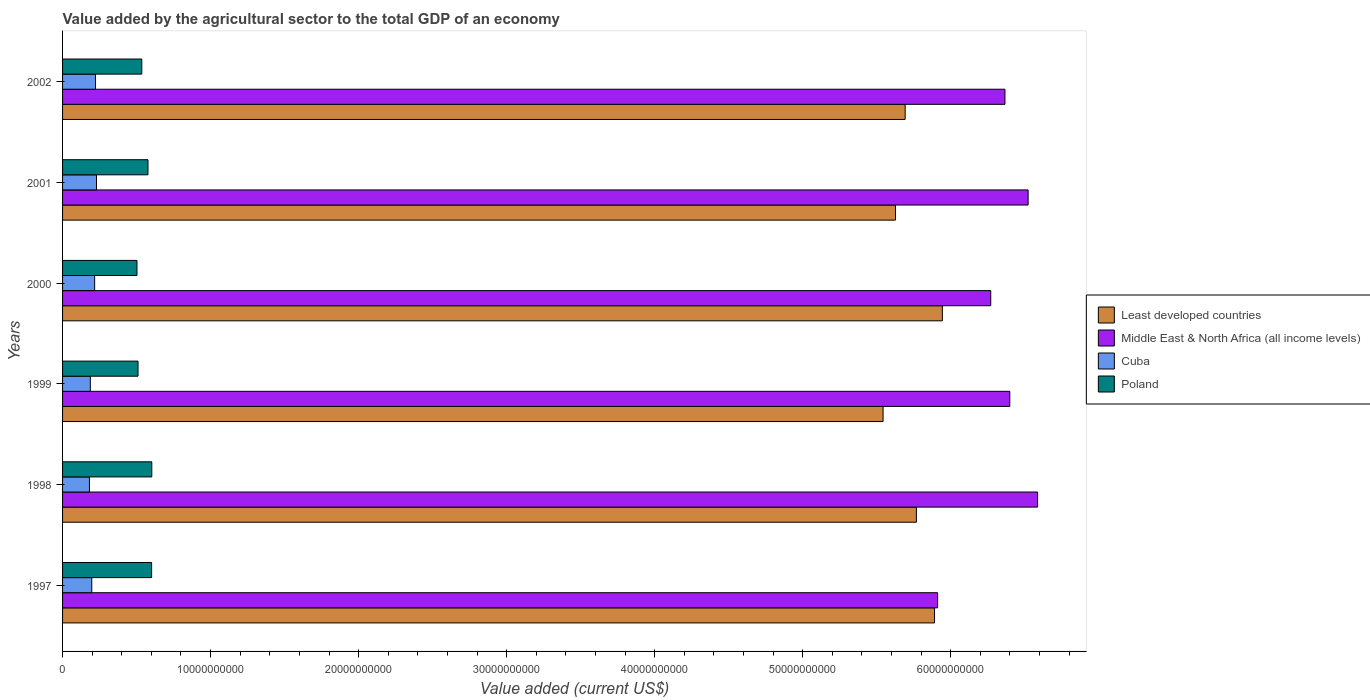How many different coloured bars are there?
Your response must be concise. 4. How many groups of bars are there?
Keep it short and to the point. 6. Are the number of bars per tick equal to the number of legend labels?
Offer a terse response. Yes. Are the number of bars on each tick of the Y-axis equal?
Offer a very short reply. Yes. How many bars are there on the 6th tick from the bottom?
Provide a short and direct response. 4. In how many cases, is the number of bars for a given year not equal to the number of legend labels?
Ensure brevity in your answer.  0. What is the value added by the agricultural sector to the total GDP in Poland in 1997?
Your response must be concise. 6.02e+09. Across all years, what is the maximum value added by the agricultural sector to the total GDP in Least developed countries?
Your answer should be very brief. 5.94e+1. Across all years, what is the minimum value added by the agricultural sector to the total GDP in Middle East & North Africa (all income levels)?
Ensure brevity in your answer.  5.91e+1. What is the total value added by the agricultural sector to the total GDP in Least developed countries in the graph?
Ensure brevity in your answer.  3.45e+11. What is the difference between the value added by the agricultural sector to the total GDP in Least developed countries in 1999 and that in 2000?
Offer a terse response. -4.00e+09. What is the difference between the value added by the agricultural sector to the total GDP in Poland in 1997 and the value added by the agricultural sector to the total GDP in Least developed countries in 1998?
Give a very brief answer. -5.17e+1. What is the average value added by the agricultural sector to the total GDP in Cuba per year?
Your answer should be compact. 2.06e+09. In the year 2001, what is the difference between the value added by the agricultural sector to the total GDP in Middle East & North Africa (all income levels) and value added by the agricultural sector to the total GDP in Least developed countries?
Give a very brief answer. 8.96e+09. In how many years, is the value added by the agricultural sector to the total GDP in Cuba greater than 10000000000 US$?
Offer a very short reply. 0. What is the ratio of the value added by the agricultural sector to the total GDP in Least developed countries in 2001 to that in 2002?
Keep it short and to the point. 0.99. Is the value added by the agricultural sector to the total GDP in Middle East & North Africa (all income levels) in 2001 less than that in 2002?
Provide a short and direct response. No. Is the difference between the value added by the agricultural sector to the total GDP in Middle East & North Africa (all income levels) in 1999 and 2002 greater than the difference between the value added by the agricultural sector to the total GDP in Least developed countries in 1999 and 2002?
Your response must be concise. Yes. What is the difference between the highest and the second highest value added by the agricultural sector to the total GDP in Middle East & North Africa (all income levels)?
Provide a succinct answer. 6.39e+08. What is the difference between the highest and the lowest value added by the agricultural sector to the total GDP in Middle East & North Africa (all income levels)?
Provide a short and direct response. 6.75e+09. Is the sum of the value added by the agricultural sector to the total GDP in Cuba in 2000 and 2002 greater than the maximum value added by the agricultural sector to the total GDP in Poland across all years?
Give a very brief answer. No. Is it the case that in every year, the sum of the value added by the agricultural sector to the total GDP in Least developed countries and value added by the agricultural sector to the total GDP in Middle East & North Africa (all income levels) is greater than the sum of value added by the agricultural sector to the total GDP in Poland and value added by the agricultural sector to the total GDP in Cuba?
Keep it short and to the point. Yes. What does the 3rd bar from the top in 1997 represents?
Your answer should be compact. Middle East & North Africa (all income levels). What does the 2nd bar from the bottom in 2000 represents?
Give a very brief answer. Middle East & North Africa (all income levels). Are all the bars in the graph horizontal?
Your answer should be compact. Yes. What is the difference between two consecutive major ticks on the X-axis?
Keep it short and to the point. 1.00e+1. Are the values on the major ticks of X-axis written in scientific E-notation?
Give a very brief answer. No. Does the graph contain any zero values?
Provide a succinct answer. No. Does the graph contain grids?
Give a very brief answer. No. Where does the legend appear in the graph?
Your answer should be compact. Center right. How are the legend labels stacked?
Your response must be concise. Vertical. What is the title of the graph?
Offer a very short reply. Value added by the agricultural sector to the total GDP of an economy. Does "Least developed countries" appear as one of the legend labels in the graph?
Keep it short and to the point. Yes. What is the label or title of the X-axis?
Your answer should be compact. Value added (current US$). What is the label or title of the Y-axis?
Provide a short and direct response. Years. What is the Value added (current US$) of Least developed countries in 1997?
Your answer should be compact. 5.89e+1. What is the Value added (current US$) of Middle East & North Africa (all income levels) in 1997?
Offer a very short reply. 5.91e+1. What is the Value added (current US$) of Cuba in 1997?
Offer a terse response. 1.97e+09. What is the Value added (current US$) of Poland in 1997?
Ensure brevity in your answer.  6.02e+09. What is the Value added (current US$) of Least developed countries in 1998?
Provide a succinct answer. 5.77e+1. What is the Value added (current US$) of Middle East & North Africa (all income levels) in 1998?
Provide a succinct answer. 6.59e+1. What is the Value added (current US$) of Cuba in 1998?
Offer a terse response. 1.82e+09. What is the Value added (current US$) of Poland in 1998?
Make the answer very short. 6.03e+09. What is the Value added (current US$) in Least developed countries in 1999?
Keep it short and to the point. 5.54e+1. What is the Value added (current US$) of Middle East & North Africa (all income levels) in 1999?
Offer a very short reply. 6.40e+1. What is the Value added (current US$) in Cuba in 1999?
Your answer should be compact. 1.87e+09. What is the Value added (current US$) in Poland in 1999?
Make the answer very short. 5.10e+09. What is the Value added (current US$) of Least developed countries in 2000?
Ensure brevity in your answer.  5.94e+1. What is the Value added (current US$) in Middle East & North Africa (all income levels) in 2000?
Provide a succinct answer. 6.27e+1. What is the Value added (current US$) in Cuba in 2000?
Provide a short and direct response. 2.17e+09. What is the Value added (current US$) of Poland in 2000?
Your answer should be compact. 5.03e+09. What is the Value added (current US$) of Least developed countries in 2001?
Ensure brevity in your answer.  5.63e+1. What is the Value added (current US$) of Middle East & North Africa (all income levels) in 2001?
Provide a short and direct response. 6.52e+1. What is the Value added (current US$) of Cuba in 2001?
Give a very brief answer. 2.29e+09. What is the Value added (current US$) of Poland in 2001?
Your answer should be very brief. 5.77e+09. What is the Value added (current US$) in Least developed countries in 2002?
Give a very brief answer. 5.69e+1. What is the Value added (current US$) of Middle East & North Africa (all income levels) in 2002?
Ensure brevity in your answer.  6.37e+1. What is the Value added (current US$) of Cuba in 2002?
Your answer should be compact. 2.23e+09. What is the Value added (current US$) of Poland in 2002?
Offer a very short reply. 5.35e+09. Across all years, what is the maximum Value added (current US$) of Least developed countries?
Keep it short and to the point. 5.94e+1. Across all years, what is the maximum Value added (current US$) of Middle East & North Africa (all income levels)?
Provide a short and direct response. 6.59e+1. Across all years, what is the maximum Value added (current US$) in Cuba?
Your response must be concise. 2.29e+09. Across all years, what is the maximum Value added (current US$) in Poland?
Provide a short and direct response. 6.03e+09. Across all years, what is the minimum Value added (current US$) in Least developed countries?
Provide a short and direct response. 5.54e+1. Across all years, what is the minimum Value added (current US$) of Middle East & North Africa (all income levels)?
Offer a terse response. 5.91e+1. Across all years, what is the minimum Value added (current US$) of Cuba?
Provide a succinct answer. 1.82e+09. Across all years, what is the minimum Value added (current US$) in Poland?
Offer a very short reply. 5.03e+09. What is the total Value added (current US$) in Least developed countries in the graph?
Make the answer very short. 3.45e+11. What is the total Value added (current US$) of Middle East & North Africa (all income levels) in the graph?
Your response must be concise. 3.81e+11. What is the total Value added (current US$) in Cuba in the graph?
Make the answer very short. 1.23e+1. What is the total Value added (current US$) of Poland in the graph?
Make the answer very short. 3.33e+1. What is the difference between the Value added (current US$) in Least developed countries in 1997 and that in 1998?
Your answer should be very brief. 1.23e+09. What is the difference between the Value added (current US$) of Middle East & North Africa (all income levels) in 1997 and that in 1998?
Your response must be concise. -6.75e+09. What is the difference between the Value added (current US$) of Cuba in 1997 and that in 1998?
Provide a short and direct response. 1.57e+08. What is the difference between the Value added (current US$) in Poland in 1997 and that in 1998?
Provide a succinct answer. -1.11e+07. What is the difference between the Value added (current US$) of Least developed countries in 1997 and that in 1999?
Make the answer very short. 3.48e+09. What is the difference between the Value added (current US$) in Middle East & North Africa (all income levels) in 1997 and that in 1999?
Ensure brevity in your answer.  -4.88e+09. What is the difference between the Value added (current US$) in Cuba in 1997 and that in 1999?
Offer a very short reply. 9.82e+07. What is the difference between the Value added (current US$) in Poland in 1997 and that in 1999?
Offer a terse response. 9.19e+08. What is the difference between the Value added (current US$) of Least developed countries in 1997 and that in 2000?
Keep it short and to the point. -5.29e+08. What is the difference between the Value added (current US$) in Middle East & North Africa (all income levels) in 1997 and that in 2000?
Ensure brevity in your answer.  -3.59e+09. What is the difference between the Value added (current US$) of Cuba in 1997 and that in 2000?
Keep it short and to the point. -1.94e+08. What is the difference between the Value added (current US$) in Poland in 1997 and that in 2000?
Provide a succinct answer. 9.90e+08. What is the difference between the Value added (current US$) in Least developed countries in 1997 and that in 2001?
Keep it short and to the point. 2.64e+09. What is the difference between the Value added (current US$) in Middle East & North Africa (all income levels) in 1997 and that in 2001?
Offer a terse response. -6.11e+09. What is the difference between the Value added (current US$) in Cuba in 1997 and that in 2001?
Offer a terse response. -3.20e+08. What is the difference between the Value added (current US$) in Poland in 1997 and that in 2001?
Provide a short and direct response. 2.46e+08. What is the difference between the Value added (current US$) in Least developed countries in 1997 and that in 2002?
Offer a terse response. 1.98e+09. What is the difference between the Value added (current US$) in Middle East & North Africa (all income levels) in 1997 and that in 2002?
Offer a terse response. -4.55e+09. What is the difference between the Value added (current US$) of Cuba in 1997 and that in 2002?
Make the answer very short. -2.53e+08. What is the difference between the Value added (current US$) of Poland in 1997 and that in 2002?
Give a very brief answer. 6.64e+08. What is the difference between the Value added (current US$) of Least developed countries in 1998 and that in 1999?
Offer a very short reply. 2.25e+09. What is the difference between the Value added (current US$) in Middle East & North Africa (all income levels) in 1998 and that in 1999?
Provide a short and direct response. 1.88e+09. What is the difference between the Value added (current US$) of Cuba in 1998 and that in 1999?
Offer a very short reply. -5.87e+07. What is the difference between the Value added (current US$) in Poland in 1998 and that in 1999?
Provide a succinct answer. 9.30e+08. What is the difference between the Value added (current US$) in Least developed countries in 1998 and that in 2000?
Your answer should be compact. -1.75e+09. What is the difference between the Value added (current US$) of Middle East & North Africa (all income levels) in 1998 and that in 2000?
Your answer should be very brief. 3.16e+09. What is the difference between the Value added (current US$) of Cuba in 1998 and that in 2000?
Your answer should be compact. -3.51e+08. What is the difference between the Value added (current US$) in Poland in 1998 and that in 2000?
Ensure brevity in your answer.  1.00e+09. What is the difference between the Value added (current US$) of Least developed countries in 1998 and that in 2001?
Give a very brief answer. 1.41e+09. What is the difference between the Value added (current US$) of Middle East & North Africa (all income levels) in 1998 and that in 2001?
Offer a very short reply. 6.39e+08. What is the difference between the Value added (current US$) in Cuba in 1998 and that in 2001?
Keep it short and to the point. -4.77e+08. What is the difference between the Value added (current US$) in Poland in 1998 and that in 2001?
Your answer should be very brief. 2.57e+08. What is the difference between the Value added (current US$) of Least developed countries in 1998 and that in 2002?
Offer a very short reply. 7.59e+08. What is the difference between the Value added (current US$) of Middle East & North Africa (all income levels) in 1998 and that in 2002?
Make the answer very short. 2.20e+09. What is the difference between the Value added (current US$) in Cuba in 1998 and that in 2002?
Your answer should be compact. -4.10e+08. What is the difference between the Value added (current US$) in Poland in 1998 and that in 2002?
Your answer should be very brief. 6.75e+08. What is the difference between the Value added (current US$) of Least developed countries in 1999 and that in 2000?
Provide a succinct answer. -4.00e+09. What is the difference between the Value added (current US$) of Middle East & North Africa (all income levels) in 1999 and that in 2000?
Offer a very short reply. 1.29e+09. What is the difference between the Value added (current US$) of Cuba in 1999 and that in 2000?
Keep it short and to the point. -2.92e+08. What is the difference between the Value added (current US$) of Poland in 1999 and that in 2000?
Offer a terse response. 7.14e+07. What is the difference between the Value added (current US$) of Least developed countries in 1999 and that in 2001?
Ensure brevity in your answer.  -8.40e+08. What is the difference between the Value added (current US$) of Middle East & North Africa (all income levels) in 1999 and that in 2001?
Give a very brief answer. -1.24e+09. What is the difference between the Value added (current US$) of Cuba in 1999 and that in 2001?
Offer a very short reply. -4.18e+08. What is the difference between the Value added (current US$) in Poland in 1999 and that in 2001?
Offer a terse response. -6.73e+08. What is the difference between the Value added (current US$) in Least developed countries in 1999 and that in 2002?
Your response must be concise. -1.49e+09. What is the difference between the Value added (current US$) of Middle East & North Africa (all income levels) in 1999 and that in 2002?
Keep it short and to the point. 3.27e+08. What is the difference between the Value added (current US$) of Cuba in 1999 and that in 2002?
Keep it short and to the point. -3.51e+08. What is the difference between the Value added (current US$) in Poland in 1999 and that in 2002?
Provide a short and direct response. -2.55e+08. What is the difference between the Value added (current US$) in Least developed countries in 2000 and that in 2001?
Keep it short and to the point. 3.16e+09. What is the difference between the Value added (current US$) of Middle East & North Africa (all income levels) in 2000 and that in 2001?
Your response must be concise. -2.53e+09. What is the difference between the Value added (current US$) of Cuba in 2000 and that in 2001?
Offer a very short reply. -1.26e+08. What is the difference between the Value added (current US$) in Poland in 2000 and that in 2001?
Offer a terse response. -7.45e+08. What is the difference between the Value added (current US$) in Least developed countries in 2000 and that in 2002?
Your answer should be very brief. 2.51e+09. What is the difference between the Value added (current US$) in Middle East & North Africa (all income levels) in 2000 and that in 2002?
Offer a very short reply. -9.59e+08. What is the difference between the Value added (current US$) in Cuba in 2000 and that in 2002?
Provide a succinct answer. -5.92e+07. What is the difference between the Value added (current US$) of Poland in 2000 and that in 2002?
Keep it short and to the point. -3.26e+08. What is the difference between the Value added (current US$) in Least developed countries in 2001 and that in 2002?
Offer a terse response. -6.51e+08. What is the difference between the Value added (current US$) in Middle East & North Africa (all income levels) in 2001 and that in 2002?
Your response must be concise. 1.57e+09. What is the difference between the Value added (current US$) of Cuba in 2001 and that in 2002?
Your answer should be compact. 6.67e+07. What is the difference between the Value added (current US$) in Poland in 2001 and that in 2002?
Provide a short and direct response. 4.18e+08. What is the difference between the Value added (current US$) of Least developed countries in 1997 and the Value added (current US$) of Middle East & North Africa (all income levels) in 1998?
Your answer should be compact. -6.96e+09. What is the difference between the Value added (current US$) of Least developed countries in 1997 and the Value added (current US$) of Cuba in 1998?
Your answer should be compact. 5.71e+1. What is the difference between the Value added (current US$) of Least developed countries in 1997 and the Value added (current US$) of Poland in 1998?
Your response must be concise. 5.29e+1. What is the difference between the Value added (current US$) of Middle East & North Africa (all income levels) in 1997 and the Value added (current US$) of Cuba in 1998?
Provide a succinct answer. 5.73e+1. What is the difference between the Value added (current US$) of Middle East & North Africa (all income levels) in 1997 and the Value added (current US$) of Poland in 1998?
Offer a terse response. 5.31e+1. What is the difference between the Value added (current US$) of Cuba in 1997 and the Value added (current US$) of Poland in 1998?
Give a very brief answer. -4.06e+09. What is the difference between the Value added (current US$) of Least developed countries in 1997 and the Value added (current US$) of Middle East & North Africa (all income levels) in 1999?
Provide a succinct answer. -5.08e+09. What is the difference between the Value added (current US$) of Least developed countries in 1997 and the Value added (current US$) of Cuba in 1999?
Offer a terse response. 5.70e+1. What is the difference between the Value added (current US$) in Least developed countries in 1997 and the Value added (current US$) in Poland in 1999?
Ensure brevity in your answer.  5.38e+1. What is the difference between the Value added (current US$) of Middle East & North Africa (all income levels) in 1997 and the Value added (current US$) of Cuba in 1999?
Make the answer very short. 5.72e+1. What is the difference between the Value added (current US$) of Middle East & North Africa (all income levels) in 1997 and the Value added (current US$) of Poland in 1999?
Give a very brief answer. 5.40e+1. What is the difference between the Value added (current US$) in Cuba in 1997 and the Value added (current US$) in Poland in 1999?
Your answer should be compact. -3.13e+09. What is the difference between the Value added (current US$) in Least developed countries in 1997 and the Value added (current US$) in Middle East & North Africa (all income levels) in 2000?
Your response must be concise. -3.80e+09. What is the difference between the Value added (current US$) of Least developed countries in 1997 and the Value added (current US$) of Cuba in 2000?
Your answer should be very brief. 5.67e+1. What is the difference between the Value added (current US$) in Least developed countries in 1997 and the Value added (current US$) in Poland in 2000?
Offer a terse response. 5.39e+1. What is the difference between the Value added (current US$) in Middle East & North Africa (all income levels) in 1997 and the Value added (current US$) in Cuba in 2000?
Offer a very short reply. 5.69e+1. What is the difference between the Value added (current US$) in Middle East & North Africa (all income levels) in 1997 and the Value added (current US$) in Poland in 2000?
Your response must be concise. 5.41e+1. What is the difference between the Value added (current US$) in Cuba in 1997 and the Value added (current US$) in Poland in 2000?
Ensure brevity in your answer.  -3.05e+09. What is the difference between the Value added (current US$) in Least developed countries in 1997 and the Value added (current US$) in Middle East & North Africa (all income levels) in 2001?
Your response must be concise. -6.32e+09. What is the difference between the Value added (current US$) of Least developed countries in 1997 and the Value added (current US$) of Cuba in 2001?
Offer a terse response. 5.66e+1. What is the difference between the Value added (current US$) in Least developed countries in 1997 and the Value added (current US$) in Poland in 2001?
Provide a succinct answer. 5.31e+1. What is the difference between the Value added (current US$) of Middle East & North Africa (all income levels) in 1997 and the Value added (current US$) of Cuba in 2001?
Make the answer very short. 5.68e+1. What is the difference between the Value added (current US$) in Middle East & North Africa (all income levels) in 1997 and the Value added (current US$) in Poland in 2001?
Provide a short and direct response. 5.33e+1. What is the difference between the Value added (current US$) of Cuba in 1997 and the Value added (current US$) of Poland in 2001?
Offer a terse response. -3.80e+09. What is the difference between the Value added (current US$) in Least developed countries in 1997 and the Value added (current US$) in Middle East & North Africa (all income levels) in 2002?
Provide a succinct answer. -4.76e+09. What is the difference between the Value added (current US$) in Least developed countries in 1997 and the Value added (current US$) in Cuba in 2002?
Your answer should be very brief. 5.67e+1. What is the difference between the Value added (current US$) in Least developed countries in 1997 and the Value added (current US$) in Poland in 2002?
Keep it short and to the point. 5.36e+1. What is the difference between the Value added (current US$) of Middle East & North Africa (all income levels) in 1997 and the Value added (current US$) of Cuba in 2002?
Provide a short and direct response. 5.69e+1. What is the difference between the Value added (current US$) in Middle East & North Africa (all income levels) in 1997 and the Value added (current US$) in Poland in 2002?
Offer a very short reply. 5.38e+1. What is the difference between the Value added (current US$) in Cuba in 1997 and the Value added (current US$) in Poland in 2002?
Your response must be concise. -3.38e+09. What is the difference between the Value added (current US$) of Least developed countries in 1998 and the Value added (current US$) of Middle East & North Africa (all income levels) in 1999?
Give a very brief answer. -6.31e+09. What is the difference between the Value added (current US$) in Least developed countries in 1998 and the Value added (current US$) in Cuba in 1999?
Your answer should be compact. 5.58e+1. What is the difference between the Value added (current US$) in Least developed countries in 1998 and the Value added (current US$) in Poland in 1999?
Provide a succinct answer. 5.26e+1. What is the difference between the Value added (current US$) in Middle East & North Africa (all income levels) in 1998 and the Value added (current US$) in Cuba in 1999?
Give a very brief answer. 6.40e+1. What is the difference between the Value added (current US$) of Middle East & North Africa (all income levels) in 1998 and the Value added (current US$) of Poland in 1999?
Provide a succinct answer. 6.08e+1. What is the difference between the Value added (current US$) of Cuba in 1998 and the Value added (current US$) of Poland in 1999?
Your answer should be very brief. -3.28e+09. What is the difference between the Value added (current US$) of Least developed countries in 1998 and the Value added (current US$) of Middle East & North Africa (all income levels) in 2000?
Give a very brief answer. -5.02e+09. What is the difference between the Value added (current US$) of Least developed countries in 1998 and the Value added (current US$) of Cuba in 2000?
Offer a very short reply. 5.55e+1. What is the difference between the Value added (current US$) in Least developed countries in 1998 and the Value added (current US$) in Poland in 2000?
Offer a very short reply. 5.27e+1. What is the difference between the Value added (current US$) of Middle East & North Africa (all income levels) in 1998 and the Value added (current US$) of Cuba in 2000?
Ensure brevity in your answer.  6.37e+1. What is the difference between the Value added (current US$) in Middle East & North Africa (all income levels) in 1998 and the Value added (current US$) in Poland in 2000?
Keep it short and to the point. 6.08e+1. What is the difference between the Value added (current US$) of Cuba in 1998 and the Value added (current US$) of Poland in 2000?
Your response must be concise. -3.21e+09. What is the difference between the Value added (current US$) of Least developed countries in 1998 and the Value added (current US$) of Middle East & North Africa (all income levels) in 2001?
Offer a terse response. -7.55e+09. What is the difference between the Value added (current US$) in Least developed countries in 1998 and the Value added (current US$) in Cuba in 2001?
Offer a terse response. 5.54e+1. What is the difference between the Value added (current US$) of Least developed countries in 1998 and the Value added (current US$) of Poland in 2001?
Provide a short and direct response. 5.19e+1. What is the difference between the Value added (current US$) in Middle East & North Africa (all income levels) in 1998 and the Value added (current US$) in Cuba in 2001?
Offer a very short reply. 6.36e+1. What is the difference between the Value added (current US$) of Middle East & North Africa (all income levels) in 1998 and the Value added (current US$) of Poland in 2001?
Make the answer very short. 6.01e+1. What is the difference between the Value added (current US$) in Cuba in 1998 and the Value added (current US$) in Poland in 2001?
Offer a very short reply. -3.96e+09. What is the difference between the Value added (current US$) of Least developed countries in 1998 and the Value added (current US$) of Middle East & North Africa (all income levels) in 2002?
Provide a succinct answer. -5.98e+09. What is the difference between the Value added (current US$) in Least developed countries in 1998 and the Value added (current US$) in Cuba in 2002?
Your response must be concise. 5.55e+1. What is the difference between the Value added (current US$) in Least developed countries in 1998 and the Value added (current US$) in Poland in 2002?
Offer a very short reply. 5.23e+1. What is the difference between the Value added (current US$) of Middle East & North Africa (all income levels) in 1998 and the Value added (current US$) of Cuba in 2002?
Offer a very short reply. 6.36e+1. What is the difference between the Value added (current US$) of Middle East & North Africa (all income levels) in 1998 and the Value added (current US$) of Poland in 2002?
Ensure brevity in your answer.  6.05e+1. What is the difference between the Value added (current US$) in Cuba in 1998 and the Value added (current US$) in Poland in 2002?
Ensure brevity in your answer.  -3.54e+09. What is the difference between the Value added (current US$) of Least developed countries in 1999 and the Value added (current US$) of Middle East & North Africa (all income levels) in 2000?
Your answer should be compact. -7.27e+09. What is the difference between the Value added (current US$) of Least developed countries in 1999 and the Value added (current US$) of Cuba in 2000?
Ensure brevity in your answer.  5.33e+1. What is the difference between the Value added (current US$) in Least developed countries in 1999 and the Value added (current US$) in Poland in 2000?
Offer a terse response. 5.04e+1. What is the difference between the Value added (current US$) in Middle East & North Africa (all income levels) in 1999 and the Value added (current US$) in Cuba in 2000?
Give a very brief answer. 6.18e+1. What is the difference between the Value added (current US$) of Middle East & North Africa (all income levels) in 1999 and the Value added (current US$) of Poland in 2000?
Your response must be concise. 5.90e+1. What is the difference between the Value added (current US$) of Cuba in 1999 and the Value added (current US$) of Poland in 2000?
Make the answer very short. -3.15e+09. What is the difference between the Value added (current US$) of Least developed countries in 1999 and the Value added (current US$) of Middle East & North Africa (all income levels) in 2001?
Keep it short and to the point. -9.80e+09. What is the difference between the Value added (current US$) of Least developed countries in 1999 and the Value added (current US$) of Cuba in 2001?
Ensure brevity in your answer.  5.31e+1. What is the difference between the Value added (current US$) in Least developed countries in 1999 and the Value added (current US$) in Poland in 2001?
Offer a terse response. 4.97e+1. What is the difference between the Value added (current US$) of Middle East & North Africa (all income levels) in 1999 and the Value added (current US$) of Cuba in 2001?
Offer a terse response. 6.17e+1. What is the difference between the Value added (current US$) in Middle East & North Africa (all income levels) in 1999 and the Value added (current US$) in Poland in 2001?
Provide a succinct answer. 5.82e+1. What is the difference between the Value added (current US$) of Cuba in 1999 and the Value added (current US$) of Poland in 2001?
Offer a very short reply. -3.90e+09. What is the difference between the Value added (current US$) in Least developed countries in 1999 and the Value added (current US$) in Middle East & North Africa (all income levels) in 2002?
Provide a short and direct response. -8.23e+09. What is the difference between the Value added (current US$) of Least developed countries in 1999 and the Value added (current US$) of Cuba in 2002?
Your answer should be very brief. 5.32e+1. What is the difference between the Value added (current US$) in Least developed countries in 1999 and the Value added (current US$) in Poland in 2002?
Offer a terse response. 5.01e+1. What is the difference between the Value added (current US$) in Middle East & North Africa (all income levels) in 1999 and the Value added (current US$) in Cuba in 2002?
Your response must be concise. 6.18e+1. What is the difference between the Value added (current US$) in Middle East & North Africa (all income levels) in 1999 and the Value added (current US$) in Poland in 2002?
Your response must be concise. 5.86e+1. What is the difference between the Value added (current US$) of Cuba in 1999 and the Value added (current US$) of Poland in 2002?
Your answer should be compact. -3.48e+09. What is the difference between the Value added (current US$) in Least developed countries in 2000 and the Value added (current US$) in Middle East & North Africa (all income levels) in 2001?
Provide a short and direct response. -5.79e+09. What is the difference between the Value added (current US$) of Least developed countries in 2000 and the Value added (current US$) of Cuba in 2001?
Your answer should be very brief. 5.71e+1. What is the difference between the Value added (current US$) in Least developed countries in 2000 and the Value added (current US$) in Poland in 2001?
Provide a short and direct response. 5.37e+1. What is the difference between the Value added (current US$) of Middle East & North Africa (all income levels) in 2000 and the Value added (current US$) of Cuba in 2001?
Provide a short and direct response. 6.04e+1. What is the difference between the Value added (current US$) in Middle East & North Africa (all income levels) in 2000 and the Value added (current US$) in Poland in 2001?
Give a very brief answer. 5.69e+1. What is the difference between the Value added (current US$) of Cuba in 2000 and the Value added (current US$) of Poland in 2001?
Provide a succinct answer. -3.60e+09. What is the difference between the Value added (current US$) in Least developed countries in 2000 and the Value added (current US$) in Middle East & North Africa (all income levels) in 2002?
Provide a short and direct response. -4.23e+09. What is the difference between the Value added (current US$) in Least developed countries in 2000 and the Value added (current US$) in Cuba in 2002?
Provide a succinct answer. 5.72e+1. What is the difference between the Value added (current US$) of Least developed countries in 2000 and the Value added (current US$) of Poland in 2002?
Your response must be concise. 5.41e+1. What is the difference between the Value added (current US$) of Middle East & North Africa (all income levels) in 2000 and the Value added (current US$) of Cuba in 2002?
Provide a succinct answer. 6.05e+1. What is the difference between the Value added (current US$) in Middle East & North Africa (all income levels) in 2000 and the Value added (current US$) in Poland in 2002?
Give a very brief answer. 5.74e+1. What is the difference between the Value added (current US$) of Cuba in 2000 and the Value added (current US$) of Poland in 2002?
Ensure brevity in your answer.  -3.19e+09. What is the difference between the Value added (current US$) of Least developed countries in 2001 and the Value added (current US$) of Middle East & North Africa (all income levels) in 2002?
Keep it short and to the point. -7.39e+09. What is the difference between the Value added (current US$) in Least developed countries in 2001 and the Value added (current US$) in Cuba in 2002?
Keep it short and to the point. 5.40e+1. What is the difference between the Value added (current US$) of Least developed countries in 2001 and the Value added (current US$) of Poland in 2002?
Ensure brevity in your answer.  5.09e+1. What is the difference between the Value added (current US$) of Middle East & North Africa (all income levels) in 2001 and the Value added (current US$) of Cuba in 2002?
Ensure brevity in your answer.  6.30e+1. What is the difference between the Value added (current US$) in Middle East & North Africa (all income levels) in 2001 and the Value added (current US$) in Poland in 2002?
Give a very brief answer. 5.99e+1. What is the difference between the Value added (current US$) of Cuba in 2001 and the Value added (current US$) of Poland in 2002?
Your answer should be very brief. -3.06e+09. What is the average Value added (current US$) of Least developed countries per year?
Offer a very short reply. 5.74e+1. What is the average Value added (current US$) in Middle East & North Africa (all income levels) per year?
Your answer should be compact. 6.34e+1. What is the average Value added (current US$) of Cuba per year?
Give a very brief answer. 2.06e+09. What is the average Value added (current US$) in Poland per year?
Offer a terse response. 5.55e+09. In the year 1997, what is the difference between the Value added (current US$) of Least developed countries and Value added (current US$) of Middle East & North Africa (all income levels)?
Make the answer very short. -2.08e+08. In the year 1997, what is the difference between the Value added (current US$) in Least developed countries and Value added (current US$) in Cuba?
Your answer should be very brief. 5.69e+1. In the year 1997, what is the difference between the Value added (current US$) of Least developed countries and Value added (current US$) of Poland?
Give a very brief answer. 5.29e+1. In the year 1997, what is the difference between the Value added (current US$) in Middle East & North Africa (all income levels) and Value added (current US$) in Cuba?
Your answer should be very brief. 5.71e+1. In the year 1997, what is the difference between the Value added (current US$) in Middle East & North Africa (all income levels) and Value added (current US$) in Poland?
Your answer should be compact. 5.31e+1. In the year 1997, what is the difference between the Value added (current US$) in Cuba and Value added (current US$) in Poland?
Offer a very short reply. -4.04e+09. In the year 1998, what is the difference between the Value added (current US$) of Least developed countries and Value added (current US$) of Middle East & North Africa (all income levels)?
Your response must be concise. -8.19e+09. In the year 1998, what is the difference between the Value added (current US$) of Least developed countries and Value added (current US$) of Cuba?
Make the answer very short. 5.59e+1. In the year 1998, what is the difference between the Value added (current US$) in Least developed countries and Value added (current US$) in Poland?
Your response must be concise. 5.17e+1. In the year 1998, what is the difference between the Value added (current US$) of Middle East & North Africa (all income levels) and Value added (current US$) of Cuba?
Offer a terse response. 6.41e+1. In the year 1998, what is the difference between the Value added (current US$) in Middle East & North Africa (all income levels) and Value added (current US$) in Poland?
Ensure brevity in your answer.  5.98e+1. In the year 1998, what is the difference between the Value added (current US$) in Cuba and Value added (current US$) in Poland?
Ensure brevity in your answer.  -4.21e+09. In the year 1999, what is the difference between the Value added (current US$) of Least developed countries and Value added (current US$) of Middle East & North Africa (all income levels)?
Give a very brief answer. -8.56e+09. In the year 1999, what is the difference between the Value added (current US$) of Least developed countries and Value added (current US$) of Cuba?
Give a very brief answer. 5.36e+1. In the year 1999, what is the difference between the Value added (current US$) of Least developed countries and Value added (current US$) of Poland?
Ensure brevity in your answer.  5.03e+1. In the year 1999, what is the difference between the Value added (current US$) in Middle East & North Africa (all income levels) and Value added (current US$) in Cuba?
Provide a succinct answer. 6.21e+1. In the year 1999, what is the difference between the Value added (current US$) in Middle East & North Africa (all income levels) and Value added (current US$) in Poland?
Provide a short and direct response. 5.89e+1. In the year 1999, what is the difference between the Value added (current US$) of Cuba and Value added (current US$) of Poland?
Give a very brief answer. -3.22e+09. In the year 2000, what is the difference between the Value added (current US$) of Least developed countries and Value added (current US$) of Middle East & North Africa (all income levels)?
Ensure brevity in your answer.  -3.27e+09. In the year 2000, what is the difference between the Value added (current US$) of Least developed countries and Value added (current US$) of Cuba?
Provide a succinct answer. 5.73e+1. In the year 2000, what is the difference between the Value added (current US$) of Least developed countries and Value added (current US$) of Poland?
Your answer should be compact. 5.44e+1. In the year 2000, what is the difference between the Value added (current US$) in Middle East & North Africa (all income levels) and Value added (current US$) in Cuba?
Offer a terse response. 6.05e+1. In the year 2000, what is the difference between the Value added (current US$) of Middle East & North Africa (all income levels) and Value added (current US$) of Poland?
Offer a very short reply. 5.77e+1. In the year 2000, what is the difference between the Value added (current US$) in Cuba and Value added (current US$) in Poland?
Keep it short and to the point. -2.86e+09. In the year 2001, what is the difference between the Value added (current US$) in Least developed countries and Value added (current US$) in Middle East & North Africa (all income levels)?
Give a very brief answer. -8.96e+09. In the year 2001, what is the difference between the Value added (current US$) of Least developed countries and Value added (current US$) of Cuba?
Your answer should be very brief. 5.40e+1. In the year 2001, what is the difference between the Value added (current US$) in Least developed countries and Value added (current US$) in Poland?
Your answer should be very brief. 5.05e+1. In the year 2001, what is the difference between the Value added (current US$) of Middle East & North Africa (all income levels) and Value added (current US$) of Cuba?
Your answer should be very brief. 6.29e+1. In the year 2001, what is the difference between the Value added (current US$) of Middle East & North Africa (all income levels) and Value added (current US$) of Poland?
Your response must be concise. 5.95e+1. In the year 2001, what is the difference between the Value added (current US$) of Cuba and Value added (current US$) of Poland?
Your response must be concise. -3.48e+09. In the year 2002, what is the difference between the Value added (current US$) in Least developed countries and Value added (current US$) in Middle East & North Africa (all income levels)?
Your answer should be very brief. -6.74e+09. In the year 2002, what is the difference between the Value added (current US$) in Least developed countries and Value added (current US$) in Cuba?
Keep it short and to the point. 5.47e+1. In the year 2002, what is the difference between the Value added (current US$) of Least developed countries and Value added (current US$) of Poland?
Give a very brief answer. 5.16e+1. In the year 2002, what is the difference between the Value added (current US$) of Middle East & North Africa (all income levels) and Value added (current US$) of Cuba?
Offer a terse response. 6.14e+1. In the year 2002, what is the difference between the Value added (current US$) in Middle East & North Africa (all income levels) and Value added (current US$) in Poland?
Provide a short and direct response. 5.83e+1. In the year 2002, what is the difference between the Value added (current US$) of Cuba and Value added (current US$) of Poland?
Ensure brevity in your answer.  -3.13e+09. What is the ratio of the Value added (current US$) in Least developed countries in 1997 to that in 1998?
Make the answer very short. 1.02. What is the ratio of the Value added (current US$) in Middle East & North Africa (all income levels) in 1997 to that in 1998?
Ensure brevity in your answer.  0.9. What is the ratio of the Value added (current US$) of Cuba in 1997 to that in 1998?
Ensure brevity in your answer.  1.09. What is the ratio of the Value added (current US$) in Least developed countries in 1997 to that in 1999?
Keep it short and to the point. 1.06. What is the ratio of the Value added (current US$) in Middle East & North Africa (all income levels) in 1997 to that in 1999?
Offer a very short reply. 0.92. What is the ratio of the Value added (current US$) in Cuba in 1997 to that in 1999?
Offer a terse response. 1.05. What is the ratio of the Value added (current US$) in Poland in 1997 to that in 1999?
Your answer should be compact. 1.18. What is the ratio of the Value added (current US$) in Least developed countries in 1997 to that in 2000?
Provide a short and direct response. 0.99. What is the ratio of the Value added (current US$) in Middle East & North Africa (all income levels) in 1997 to that in 2000?
Provide a succinct answer. 0.94. What is the ratio of the Value added (current US$) of Cuba in 1997 to that in 2000?
Offer a terse response. 0.91. What is the ratio of the Value added (current US$) of Poland in 1997 to that in 2000?
Offer a very short reply. 1.2. What is the ratio of the Value added (current US$) of Least developed countries in 1997 to that in 2001?
Provide a short and direct response. 1.05. What is the ratio of the Value added (current US$) of Middle East & North Africa (all income levels) in 1997 to that in 2001?
Provide a short and direct response. 0.91. What is the ratio of the Value added (current US$) of Cuba in 1997 to that in 2001?
Ensure brevity in your answer.  0.86. What is the ratio of the Value added (current US$) in Poland in 1997 to that in 2001?
Offer a terse response. 1.04. What is the ratio of the Value added (current US$) in Least developed countries in 1997 to that in 2002?
Give a very brief answer. 1.03. What is the ratio of the Value added (current US$) in Middle East & North Africa (all income levels) in 1997 to that in 2002?
Offer a terse response. 0.93. What is the ratio of the Value added (current US$) in Cuba in 1997 to that in 2002?
Your answer should be very brief. 0.89. What is the ratio of the Value added (current US$) in Poland in 1997 to that in 2002?
Ensure brevity in your answer.  1.12. What is the ratio of the Value added (current US$) of Least developed countries in 1998 to that in 1999?
Keep it short and to the point. 1.04. What is the ratio of the Value added (current US$) of Middle East & North Africa (all income levels) in 1998 to that in 1999?
Provide a succinct answer. 1.03. What is the ratio of the Value added (current US$) in Cuba in 1998 to that in 1999?
Your response must be concise. 0.97. What is the ratio of the Value added (current US$) of Poland in 1998 to that in 1999?
Provide a succinct answer. 1.18. What is the ratio of the Value added (current US$) of Least developed countries in 1998 to that in 2000?
Make the answer very short. 0.97. What is the ratio of the Value added (current US$) in Middle East & North Africa (all income levels) in 1998 to that in 2000?
Provide a succinct answer. 1.05. What is the ratio of the Value added (current US$) in Cuba in 1998 to that in 2000?
Offer a very short reply. 0.84. What is the ratio of the Value added (current US$) in Poland in 1998 to that in 2000?
Offer a terse response. 1.2. What is the ratio of the Value added (current US$) in Least developed countries in 1998 to that in 2001?
Your response must be concise. 1.03. What is the ratio of the Value added (current US$) of Middle East & North Africa (all income levels) in 1998 to that in 2001?
Give a very brief answer. 1.01. What is the ratio of the Value added (current US$) in Cuba in 1998 to that in 2001?
Make the answer very short. 0.79. What is the ratio of the Value added (current US$) in Poland in 1998 to that in 2001?
Provide a succinct answer. 1.04. What is the ratio of the Value added (current US$) of Least developed countries in 1998 to that in 2002?
Keep it short and to the point. 1.01. What is the ratio of the Value added (current US$) of Middle East & North Africa (all income levels) in 1998 to that in 2002?
Offer a very short reply. 1.03. What is the ratio of the Value added (current US$) in Cuba in 1998 to that in 2002?
Your answer should be compact. 0.82. What is the ratio of the Value added (current US$) of Poland in 1998 to that in 2002?
Keep it short and to the point. 1.13. What is the ratio of the Value added (current US$) of Least developed countries in 1999 to that in 2000?
Offer a terse response. 0.93. What is the ratio of the Value added (current US$) of Middle East & North Africa (all income levels) in 1999 to that in 2000?
Your answer should be very brief. 1.02. What is the ratio of the Value added (current US$) of Cuba in 1999 to that in 2000?
Your response must be concise. 0.87. What is the ratio of the Value added (current US$) of Poland in 1999 to that in 2000?
Provide a short and direct response. 1.01. What is the ratio of the Value added (current US$) in Least developed countries in 1999 to that in 2001?
Provide a short and direct response. 0.99. What is the ratio of the Value added (current US$) in Middle East & North Africa (all income levels) in 1999 to that in 2001?
Provide a succinct answer. 0.98. What is the ratio of the Value added (current US$) in Cuba in 1999 to that in 2001?
Make the answer very short. 0.82. What is the ratio of the Value added (current US$) of Poland in 1999 to that in 2001?
Your answer should be very brief. 0.88. What is the ratio of the Value added (current US$) in Least developed countries in 1999 to that in 2002?
Offer a very short reply. 0.97. What is the ratio of the Value added (current US$) of Middle East & North Africa (all income levels) in 1999 to that in 2002?
Make the answer very short. 1.01. What is the ratio of the Value added (current US$) of Cuba in 1999 to that in 2002?
Your response must be concise. 0.84. What is the ratio of the Value added (current US$) in Poland in 1999 to that in 2002?
Offer a terse response. 0.95. What is the ratio of the Value added (current US$) of Least developed countries in 2000 to that in 2001?
Offer a very short reply. 1.06. What is the ratio of the Value added (current US$) in Middle East & North Africa (all income levels) in 2000 to that in 2001?
Make the answer very short. 0.96. What is the ratio of the Value added (current US$) of Cuba in 2000 to that in 2001?
Provide a succinct answer. 0.95. What is the ratio of the Value added (current US$) of Poland in 2000 to that in 2001?
Give a very brief answer. 0.87. What is the ratio of the Value added (current US$) in Least developed countries in 2000 to that in 2002?
Offer a very short reply. 1.04. What is the ratio of the Value added (current US$) in Middle East & North Africa (all income levels) in 2000 to that in 2002?
Provide a succinct answer. 0.98. What is the ratio of the Value added (current US$) in Cuba in 2000 to that in 2002?
Keep it short and to the point. 0.97. What is the ratio of the Value added (current US$) of Poland in 2000 to that in 2002?
Make the answer very short. 0.94. What is the ratio of the Value added (current US$) of Least developed countries in 2001 to that in 2002?
Ensure brevity in your answer.  0.99. What is the ratio of the Value added (current US$) in Middle East & North Africa (all income levels) in 2001 to that in 2002?
Your answer should be compact. 1.02. What is the ratio of the Value added (current US$) in Cuba in 2001 to that in 2002?
Give a very brief answer. 1.03. What is the ratio of the Value added (current US$) in Poland in 2001 to that in 2002?
Offer a terse response. 1.08. What is the difference between the highest and the second highest Value added (current US$) of Least developed countries?
Offer a terse response. 5.29e+08. What is the difference between the highest and the second highest Value added (current US$) in Middle East & North Africa (all income levels)?
Your answer should be compact. 6.39e+08. What is the difference between the highest and the second highest Value added (current US$) of Cuba?
Offer a very short reply. 6.67e+07. What is the difference between the highest and the second highest Value added (current US$) in Poland?
Make the answer very short. 1.11e+07. What is the difference between the highest and the lowest Value added (current US$) in Least developed countries?
Offer a terse response. 4.00e+09. What is the difference between the highest and the lowest Value added (current US$) in Middle East & North Africa (all income levels)?
Your answer should be compact. 6.75e+09. What is the difference between the highest and the lowest Value added (current US$) in Cuba?
Ensure brevity in your answer.  4.77e+08. What is the difference between the highest and the lowest Value added (current US$) of Poland?
Your response must be concise. 1.00e+09. 